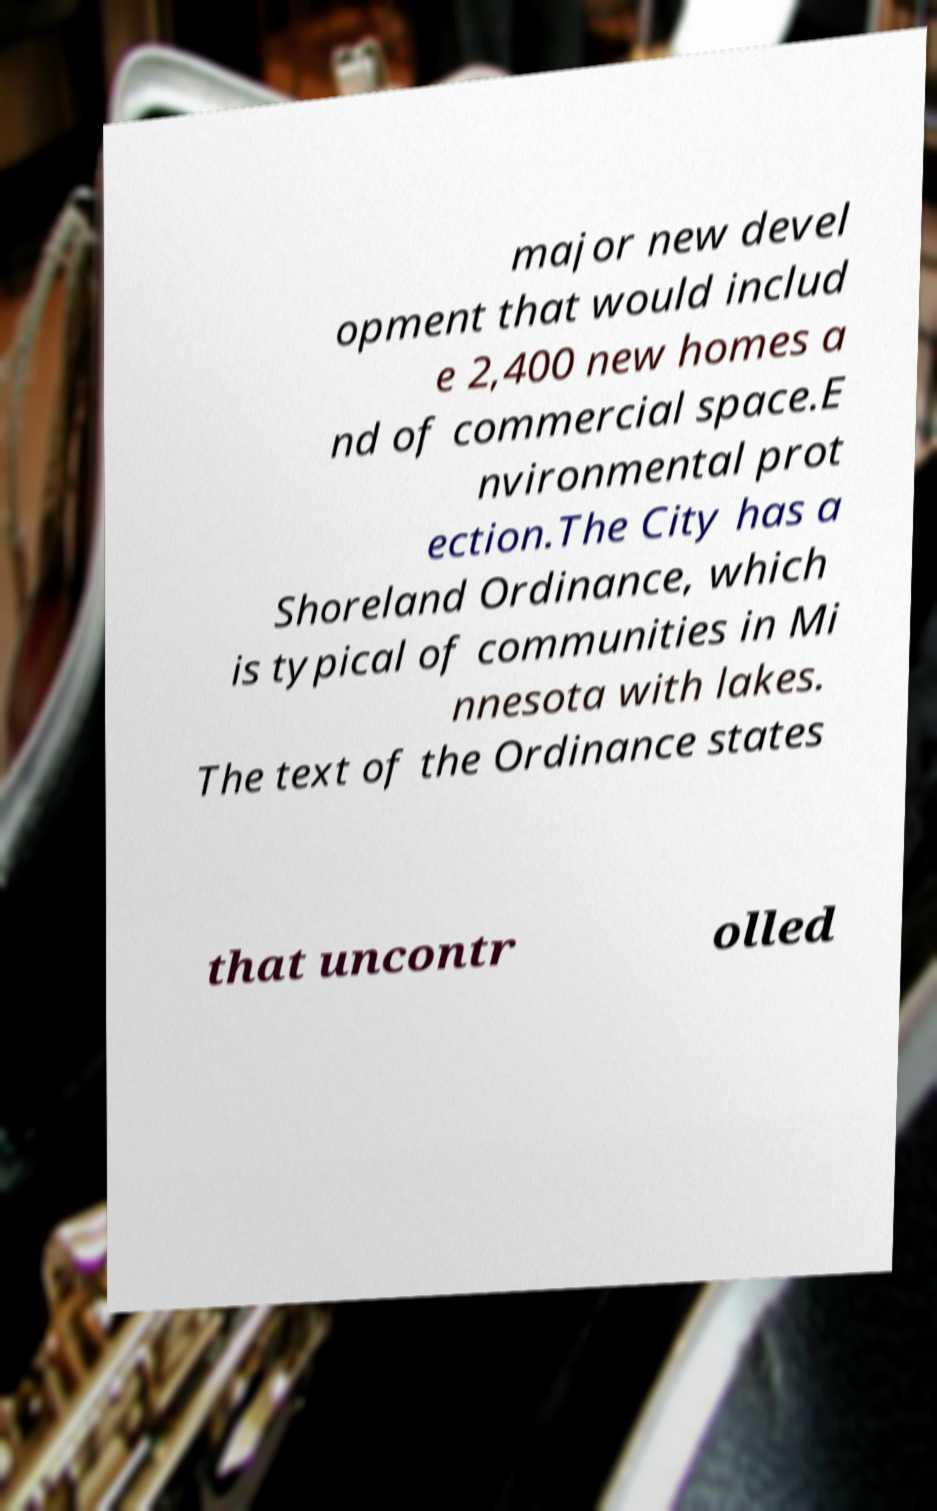Please identify and transcribe the text found in this image. major new devel opment that would includ e 2,400 new homes a nd of commercial space.E nvironmental prot ection.The City has a Shoreland Ordinance, which is typical of communities in Mi nnesota with lakes. The text of the Ordinance states that uncontr olled 